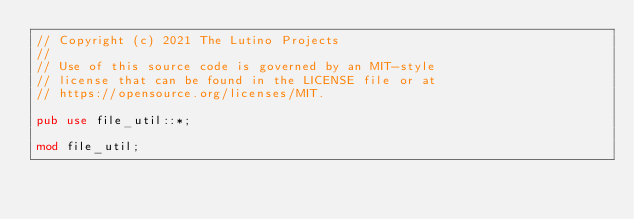Convert code to text. <code><loc_0><loc_0><loc_500><loc_500><_Rust_>// Copyright (c) 2021 The Lutino Projects
//
// Use of this source code is governed by an MIT-style
// license that can be found in the LICENSE file or at
// https://opensource.org/licenses/MIT.

pub use file_util::*;

mod file_util;
</code> 